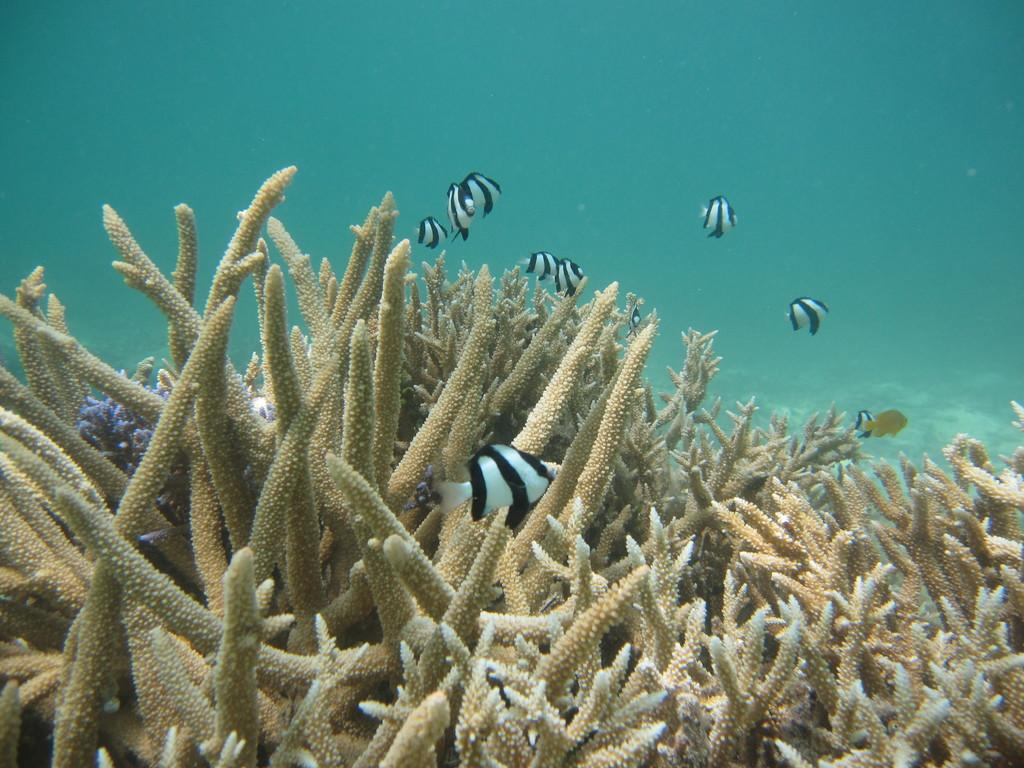What type of environment is shown in the image? The image depicts an underwater environment. What living creatures can be seen in the image? There are fishes visible in the image. What else can be seen in the image besides the fishes? There are objects that resemble plants in the image. What type of suggestion can be seen in the image? There is no suggestion present in the image; it depicts an underwater environment with fishes and plant-like objects. 